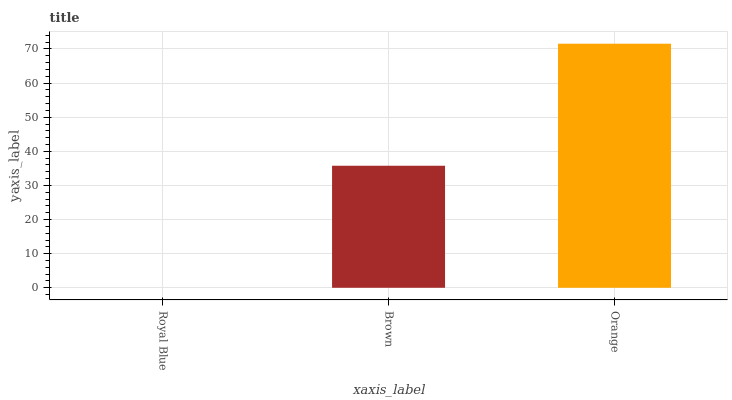Is Royal Blue the minimum?
Answer yes or no. Yes. Is Orange the maximum?
Answer yes or no. Yes. Is Brown the minimum?
Answer yes or no. No. Is Brown the maximum?
Answer yes or no. No. Is Brown greater than Royal Blue?
Answer yes or no. Yes. Is Royal Blue less than Brown?
Answer yes or no. Yes. Is Royal Blue greater than Brown?
Answer yes or no. No. Is Brown less than Royal Blue?
Answer yes or no. No. Is Brown the high median?
Answer yes or no. Yes. Is Brown the low median?
Answer yes or no. Yes. Is Royal Blue the high median?
Answer yes or no. No. Is Orange the low median?
Answer yes or no. No. 